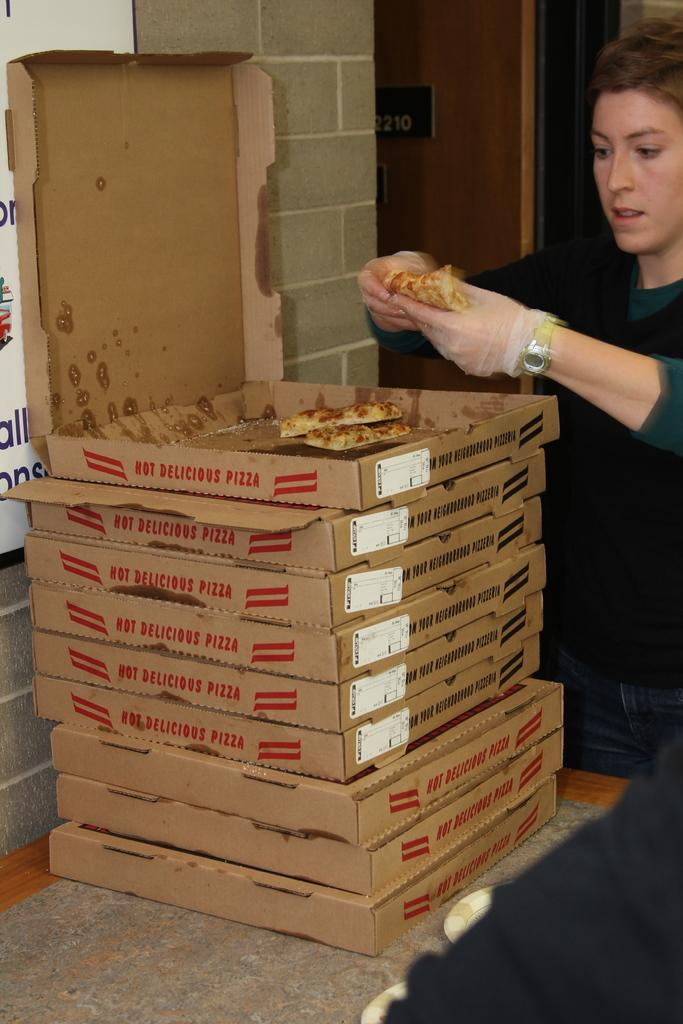<image>
Offer a succinct explanation of the picture presented. A stack of pizza boxes that are labeled hot and delicious. 